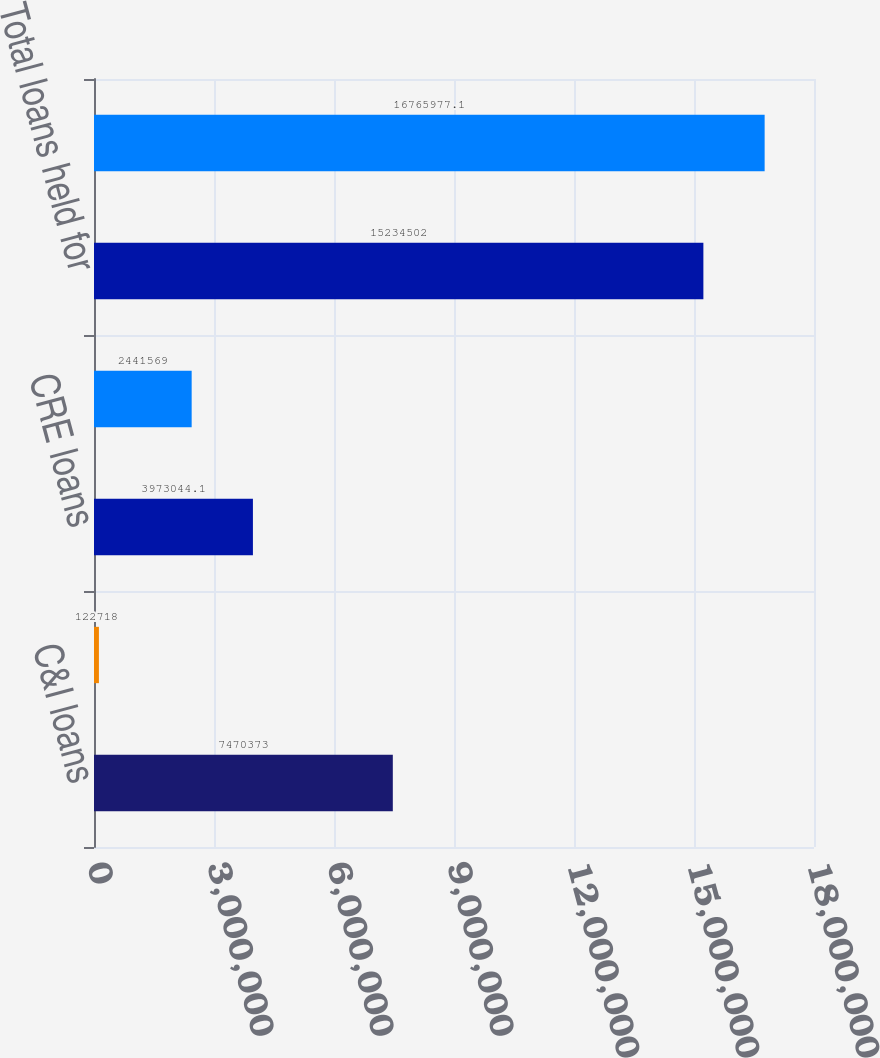Convert chart to OTSL. <chart><loc_0><loc_0><loc_500><loc_500><bar_chart><fcel>C&I loans<fcel>CRE construction loans<fcel>CRE loans<fcel>Residential mortgage loans<fcel>Total loans held for<fcel>Total loans<nl><fcel>7.47037e+06<fcel>122718<fcel>3.97304e+06<fcel>2.44157e+06<fcel>1.52345e+07<fcel>1.6766e+07<nl></chart> 